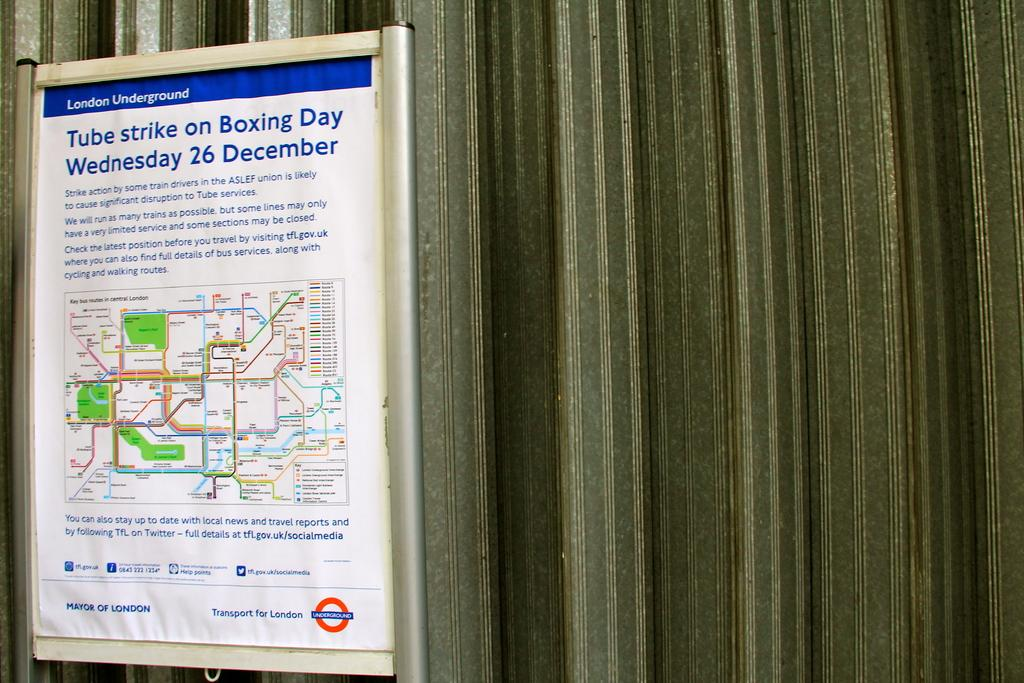<image>
Share a concise interpretation of the image provided. White sign that says "Tube Strike on Boxing Day" which takes place on Wednesday. 